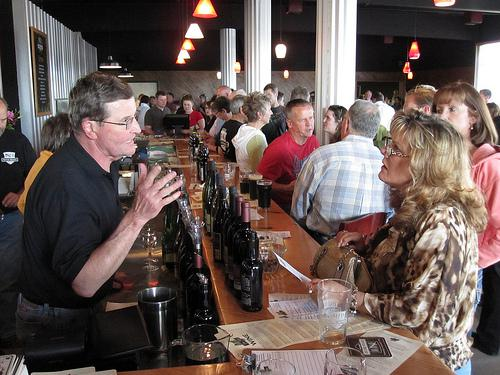Question: what kind of pants is the bartender wearing?
Choices:
A. Black pants.
B. Khakis.
C. Red jeans.
D. Jeans.
Answer with the letter. Answer: D Question: where was the picture taken?
Choices:
A. At school.
B. In a bar.
C. In a restaurant.
D. At a diner.
Answer with the letter. Answer: B Question: what kind of light is shining in from the window, on the far right?
Choices:
A. A street light.
B. Car headlights.
C. A flashlight.
D. Sunlight.
Answer with the letter. Answer: D Question: what is the bar surface made of?
Choices:
A. Wood.
B. Chrome.
C. Marble.
D. Tile.
Answer with the letter. Answer: A Question: what color shirt is the bartender wearing?
Choices:
A. Purple.
B. Black.
C. Pink.
D. Red.
Answer with the letter. Answer: B Question: what is the bartender wearing on his face?
Choices:
A. A mask.
B. An eyepatch.
C. Sunscreen.
D. Glasses.
Answer with the letter. Answer: D 